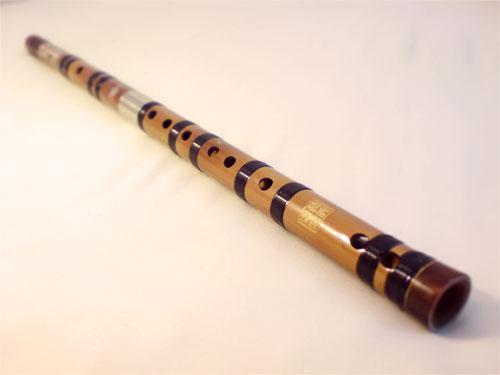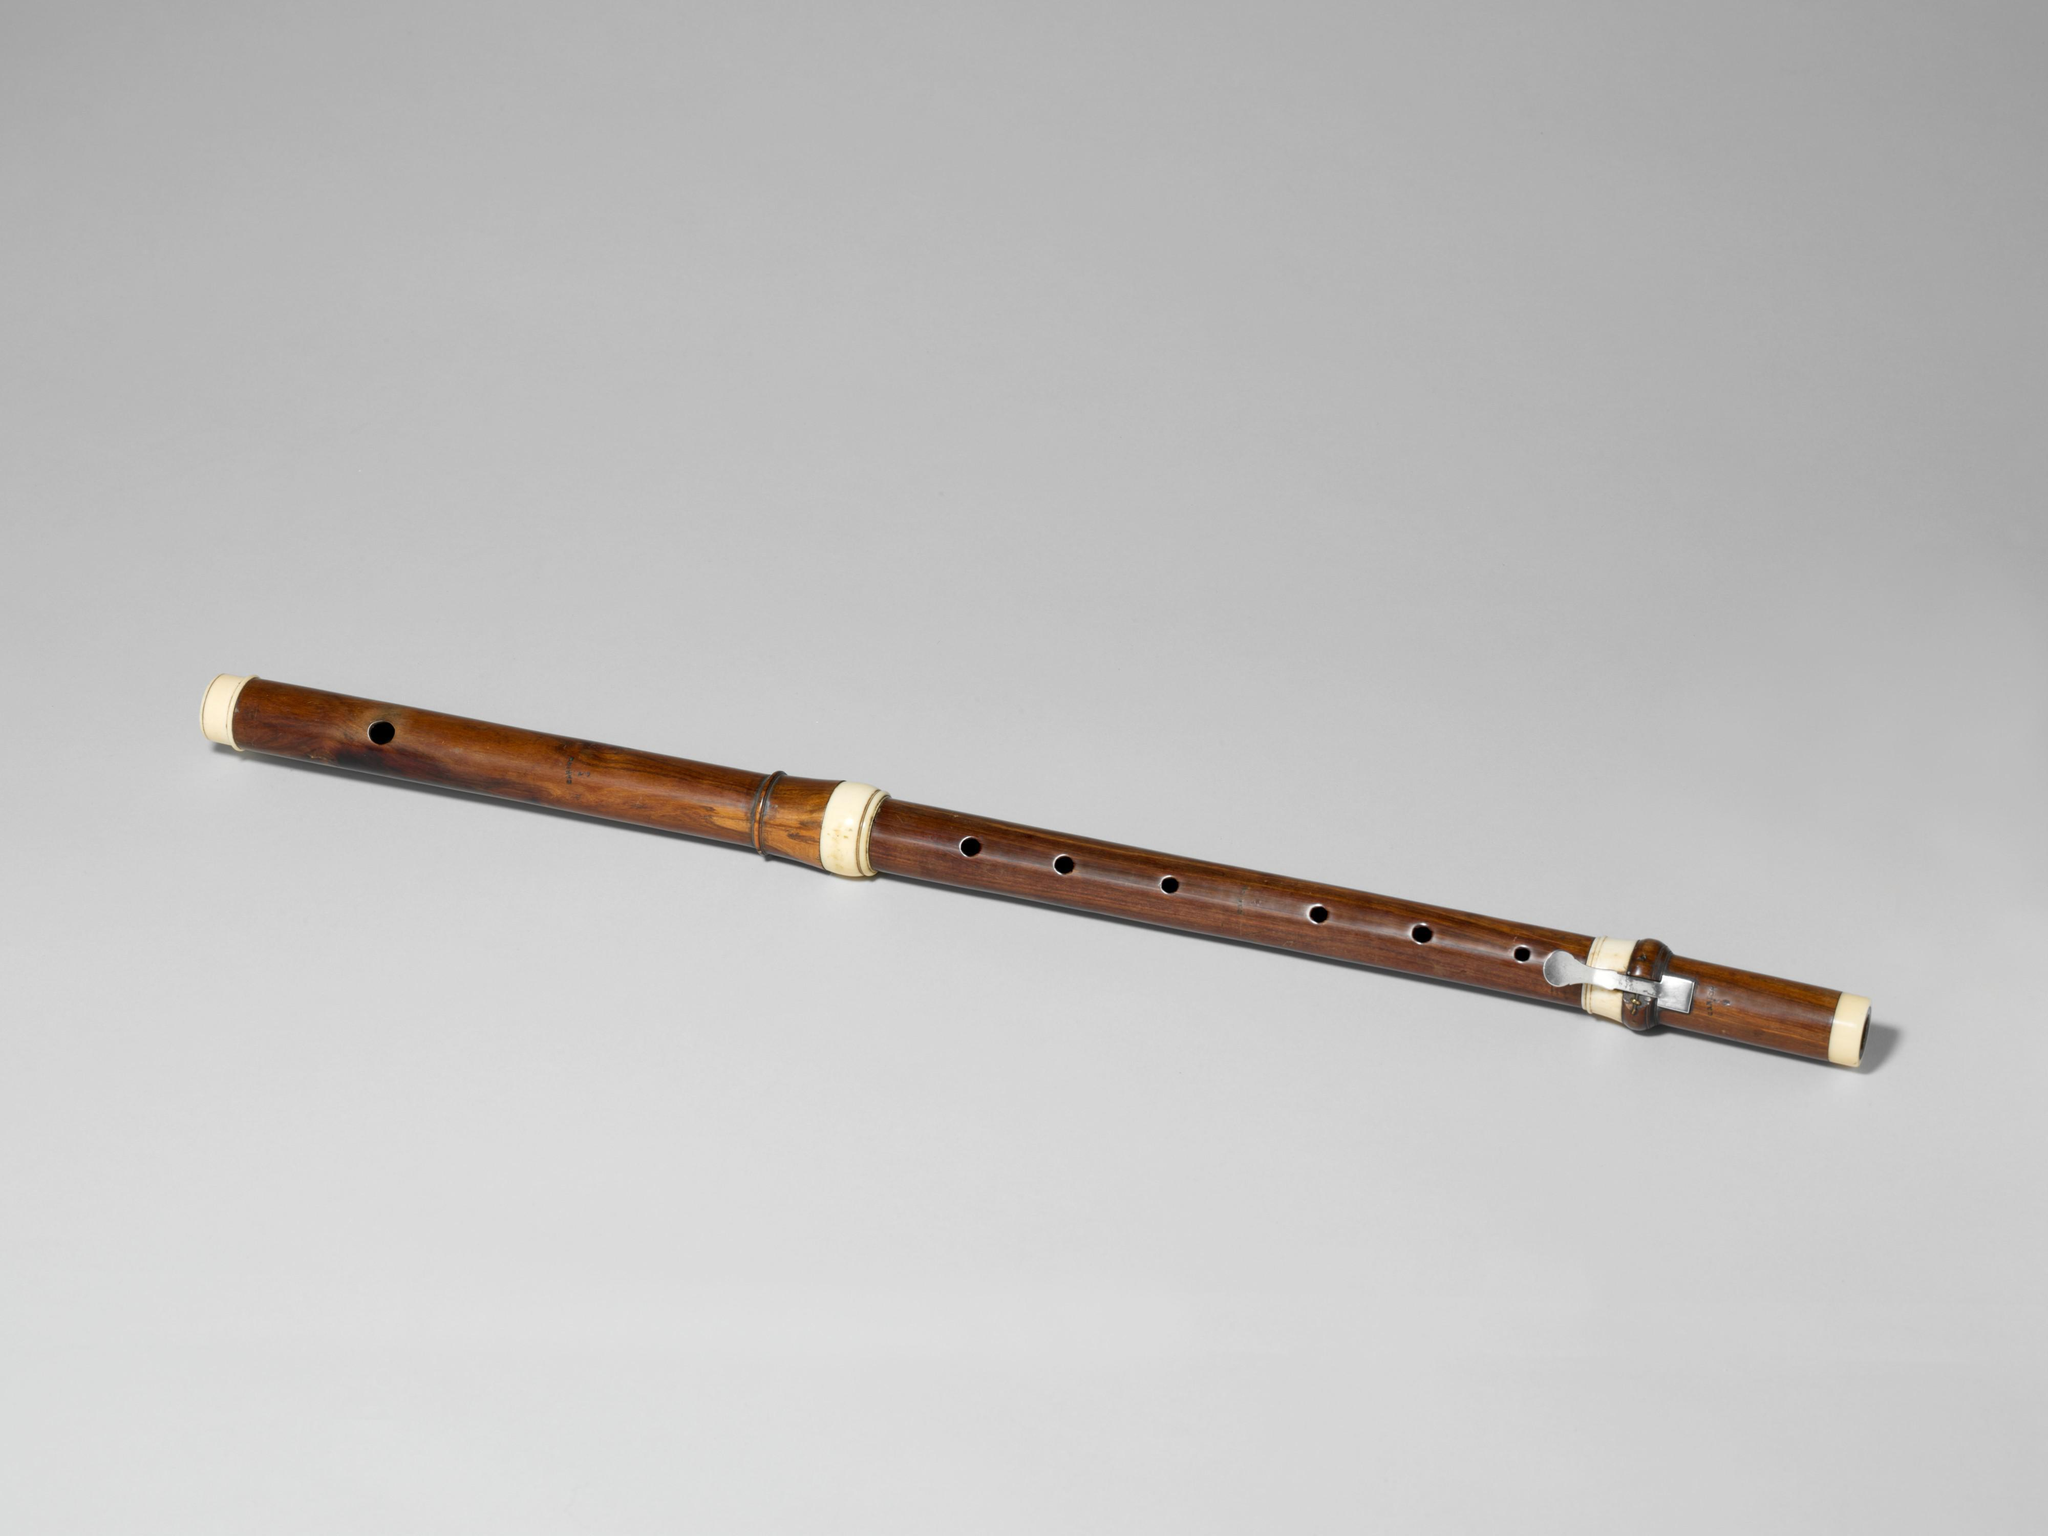The first image is the image on the left, the second image is the image on the right. Evaluate the accuracy of this statement regarding the images: "Each image contains only one flute, which is displayed somewhat horizontally.". Is it true? Answer yes or no. Yes. The first image is the image on the left, the second image is the image on the right. For the images shown, is this caption "In at least one image there is a brown wooden flute with only 7 drilled holes in it." true? Answer yes or no. Yes. 